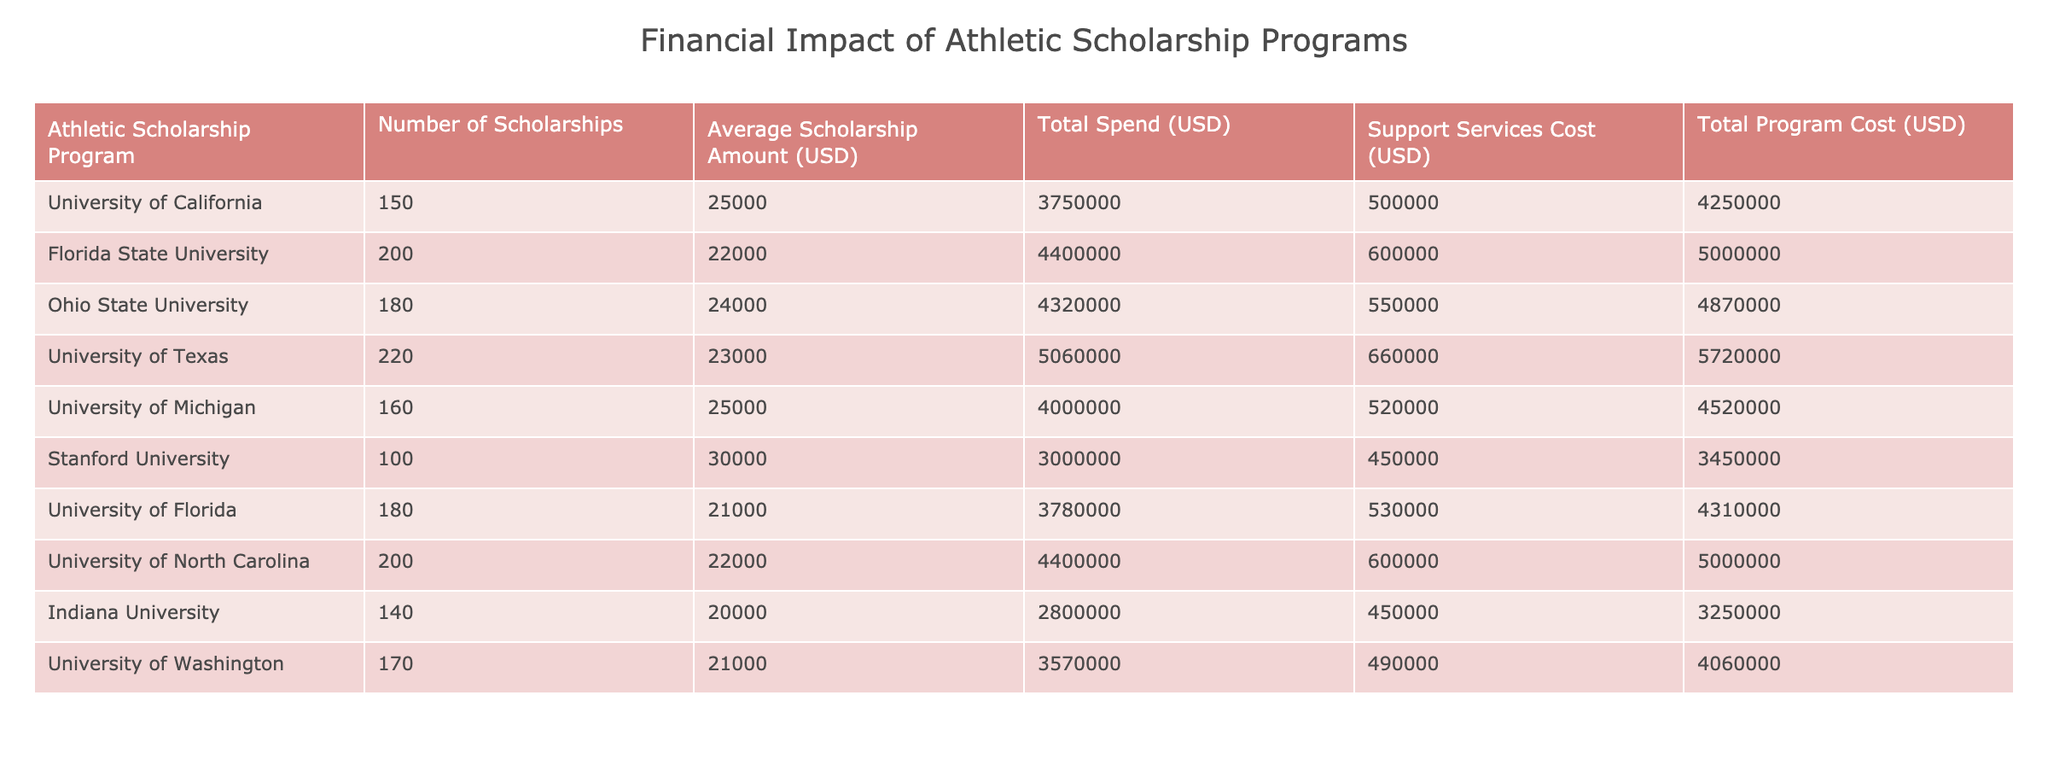What university offers the highest average scholarship amount? By examining the "Average Scholarship Amount (USD)" column, Stanford University has the highest value at 30000 USD.
Answer: 30000 USD How many total scholarships are offered by the University of Texas and University of North Carolina combined? The number of scholarships for the University of Texas is 220 and for the University of North Carolina is 200. Adding these together gives 220 + 200 = 420.
Answer: 420 What is the total cost of the athletic scholarship program for Florida State University? The "Total Program Cost (USD)" for Florida State University is listed directly as 5000000 USD.
Answer: 5000000 USD Is the support services cost at Ohio State University greater than the total spend? The support services cost for Ohio State University is 550000 USD and the total spend is 4320000 USD. Since 550000 is less than 4320000, the statement is false.
Answer: No What is the average total program cost for the universities listed? To find the average, first sum all the "Total Program Cost (USD)" values: 4250000 + 5000000 + 4870000 + 5720000 + 4520000 + 3450000 + 4310000 + 5000000 + 3250000 + 4060000 = 47600000. Then divide by the number of universities (10): 47600000 / 10 = 4760000.
Answer: 4760000 USD How much more does the University of California spend on support services compared to Indiana University? The support services cost for University of California is 500000 USD and for Indiana University is 450000 USD. The difference is 500000 - 450000 = 50000 USD.
Answer: 50000 USD Which university has the lowest total spend and what is the amount? Looking through the "Total Spend (USD)" column, Indiana University has the lowest total spend at 2800000 USD.
Answer: 2800000 USD Which university has the highest total program cost among the listed institutions? The "Total Program Cost (USD)" for the University of Texas is the highest at 5720000 USD, as verified by comparing all values in that column.
Answer: 5720000 USD What is the total spend across all universities? Adding the total spend for all universities gives: 3750000 + 4400000 + 4320000 + 5060000 + 4000000 + 3000000 + 3780000 + 4400000 + 2800000 + 3570000 = 42100000 USD.
Answer: 42100000 USD 